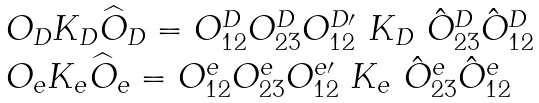Convert formula to latex. <formula><loc_0><loc_0><loc_500><loc_500>\begin{array} { l } O _ { D } K _ { D } \widehat { O } _ { D } = O _ { 1 2 } ^ { D } O _ { 2 3 } ^ { D } O _ { 1 2 } ^ { D \prime } \ K _ { D } \ \hat { O } _ { 2 3 } ^ { D } \hat { O } _ { 1 2 } ^ { D } \\ O _ { e } K _ { e } \widehat { O } _ { e } = O _ { 1 2 } ^ { e } O _ { 2 3 } ^ { e } O _ { 1 2 } ^ { e \prime } \ K _ { e } \ \hat { O } _ { 2 3 } ^ { e } \hat { O } _ { 1 2 } ^ { e } \end{array}</formula> 